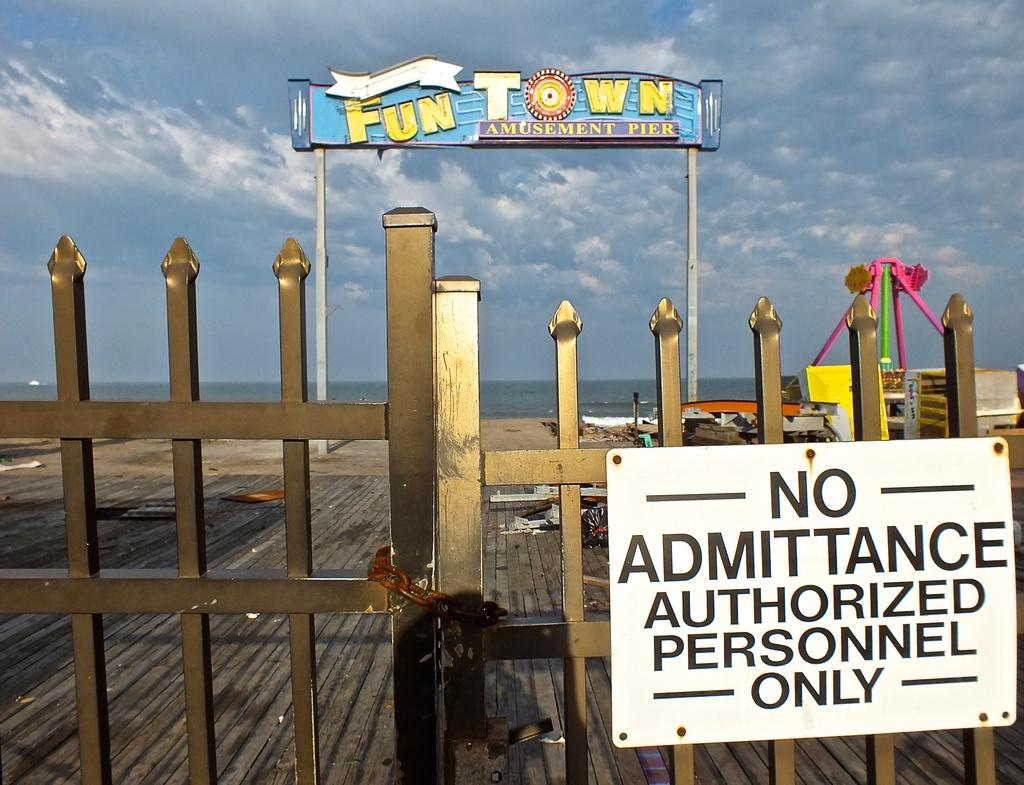<image>
Render a clear and concise summary of the photo. A closed gate says there is no admittance to the amusement pier. 